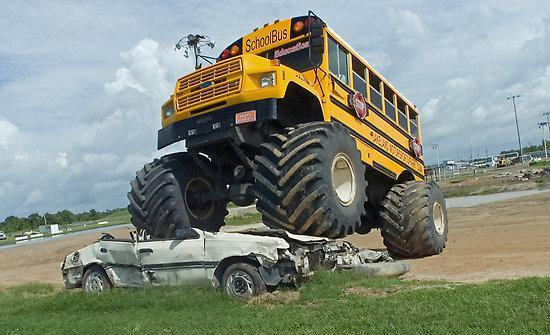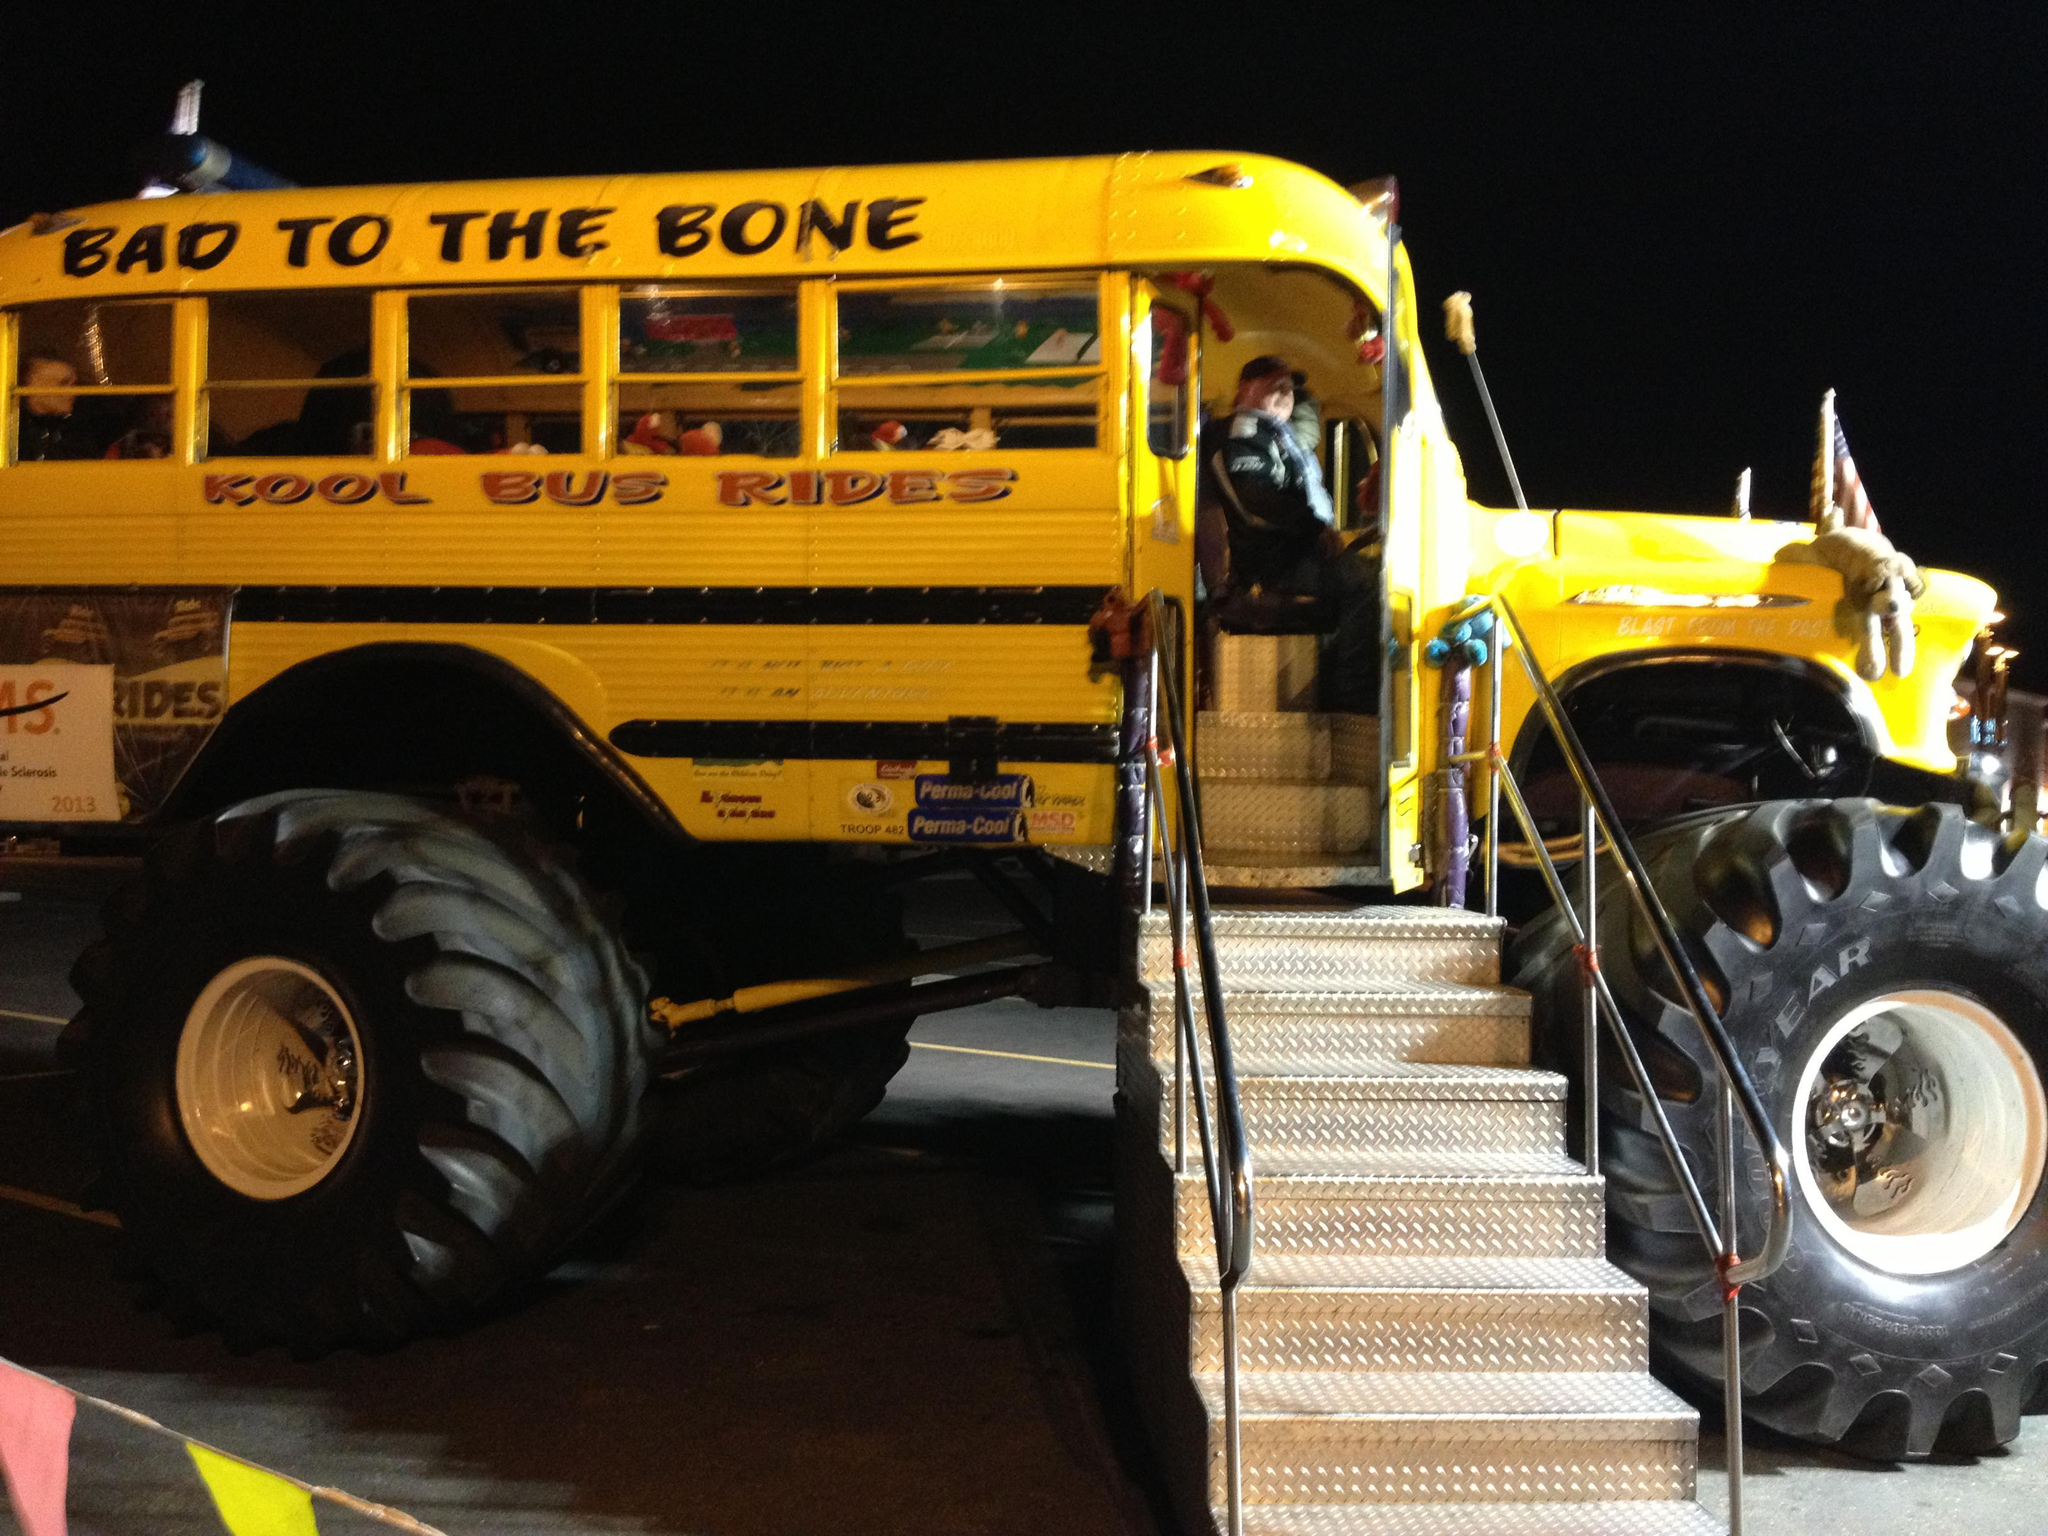The first image is the image on the left, the second image is the image on the right. For the images displayed, is the sentence "In the left image a monster bus is driving over another vehicle." factually correct? Answer yes or no. Yes. The first image is the image on the left, the second image is the image on the right. Examine the images to the left and right. Is the description "One image shows a big-wheeled yellow school bus with its front tires on top of a squashed white car." accurate? Answer yes or no. Yes. 